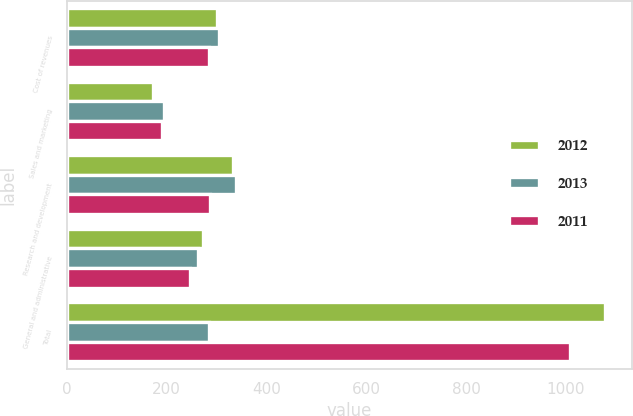<chart> <loc_0><loc_0><loc_500><loc_500><stacked_bar_chart><ecel><fcel>Cost of revenues<fcel>Sales and marketing<fcel>Research and development<fcel>General and administrative<fcel>Total<nl><fcel>2012<fcel>301<fcel>172<fcel>333<fcel>273<fcel>1079<nl><fcel>2013<fcel>304<fcel>194<fcel>339<fcel>262<fcel>285.5<nl><fcel>2011<fcel>284<fcel>191<fcel>287<fcel>247<fcel>1009<nl></chart> 